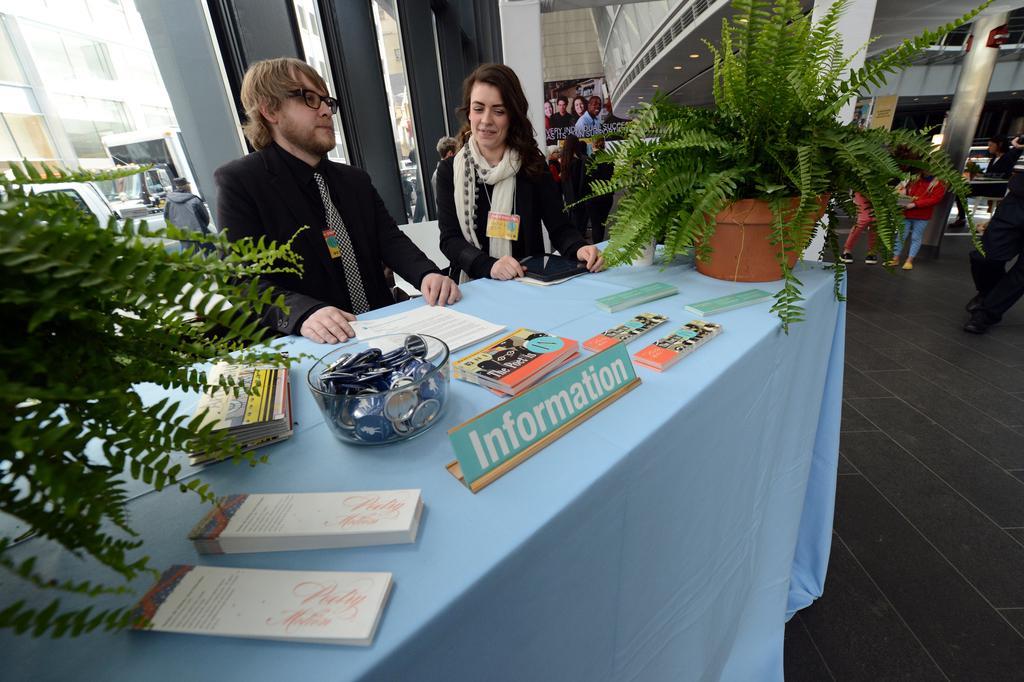Describe this image in one or two sentences. In this picture there are two people sitting on the chairs in front of the table on which there some papers, books, two plants and a bowl in which some things are placed and beside them there are some people standing. 